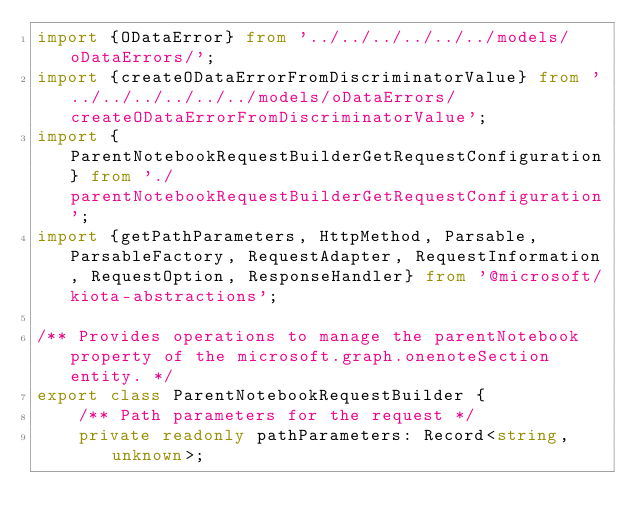<code> <loc_0><loc_0><loc_500><loc_500><_TypeScript_>import {ODataError} from '../../../../../../models/oDataErrors/';
import {createODataErrorFromDiscriminatorValue} from '../../../../../../models/oDataErrors/createODataErrorFromDiscriminatorValue';
import {ParentNotebookRequestBuilderGetRequestConfiguration} from './parentNotebookRequestBuilderGetRequestConfiguration';
import {getPathParameters, HttpMethod, Parsable, ParsableFactory, RequestAdapter, RequestInformation, RequestOption, ResponseHandler} from '@microsoft/kiota-abstractions';

/** Provides operations to manage the parentNotebook property of the microsoft.graph.onenoteSection entity. */
export class ParentNotebookRequestBuilder {
    /** Path parameters for the request */
    private readonly pathParameters: Record<string, unknown>;</code> 